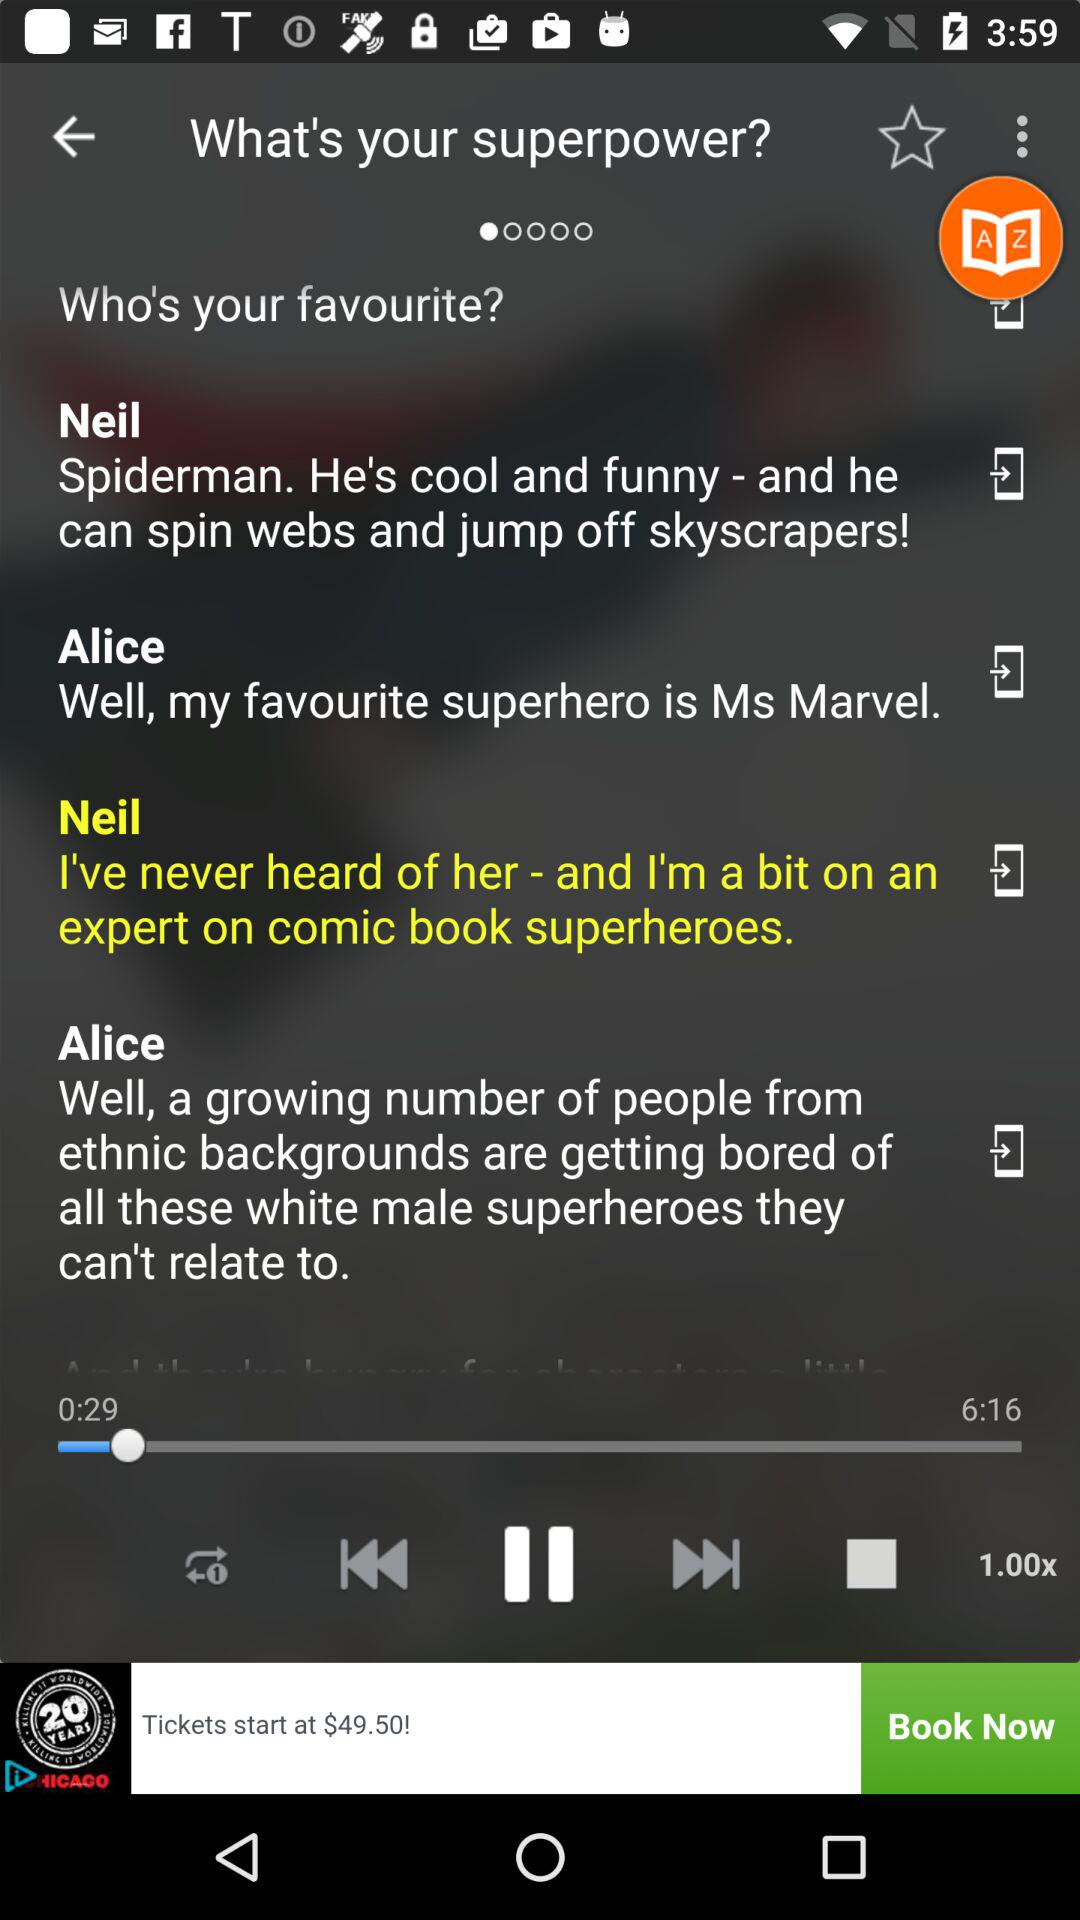What's the duration? The duration is 6 minutes 16 seconds. 